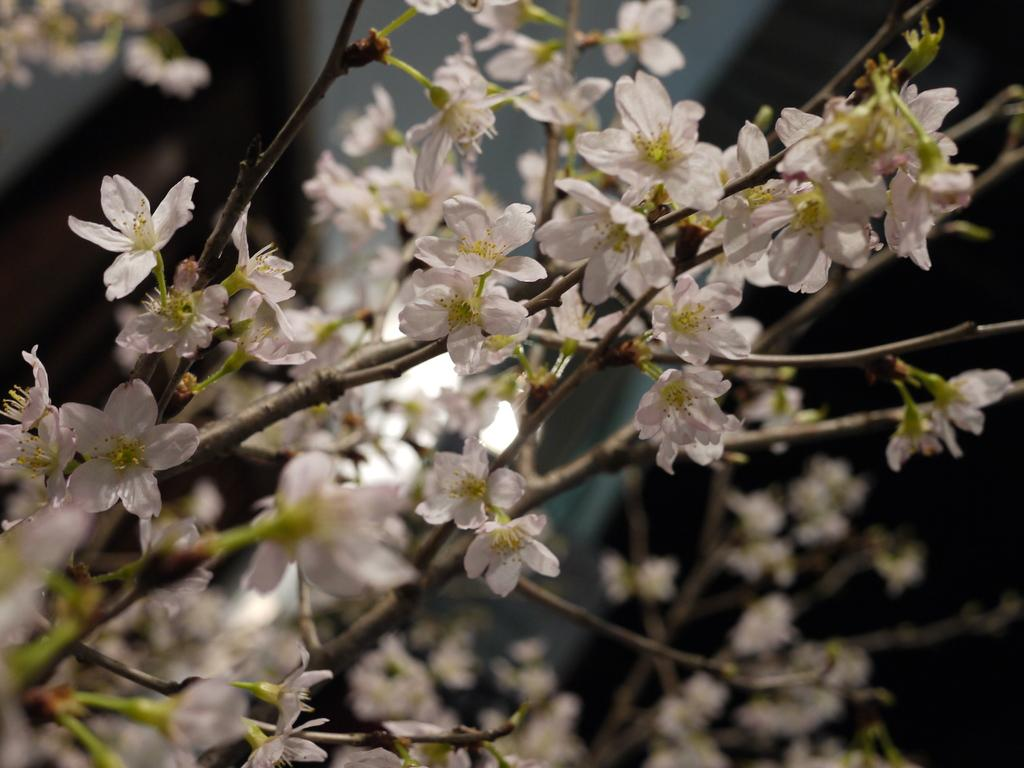What type of living organisms are in the image? The image contains plants. What specific feature can be observed on the plants? The plants have flowers. What color are the flowers? The flowers are white in color. How would you describe the background of the image? The background of the image is blurred. What type of glue is being used to hold the letter in the image? There is no glue or letter present in the image; it features plants with white flowers and a blurred background. 